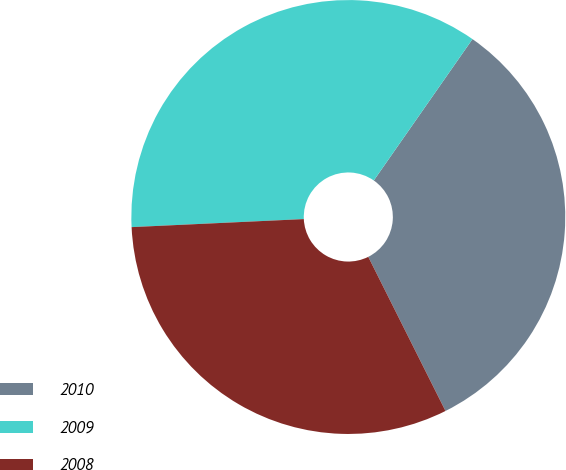Convert chart to OTSL. <chart><loc_0><loc_0><loc_500><loc_500><pie_chart><fcel>2010<fcel>2009<fcel>2008<nl><fcel>32.91%<fcel>35.44%<fcel>31.65%<nl></chart> 